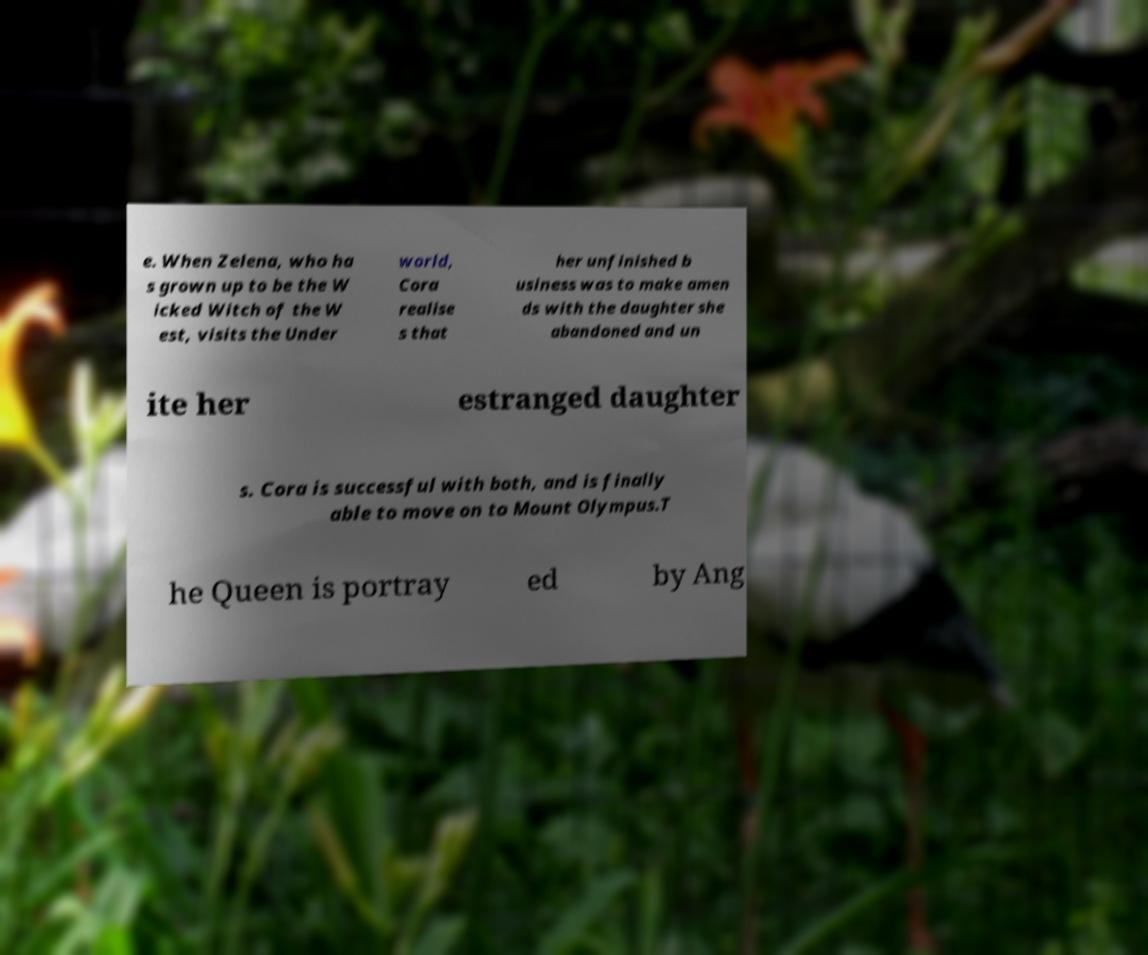For documentation purposes, I need the text within this image transcribed. Could you provide that? e. When Zelena, who ha s grown up to be the W icked Witch of the W est, visits the Under world, Cora realise s that her unfinished b usiness was to make amen ds with the daughter she abandoned and un ite her estranged daughter s. Cora is successful with both, and is finally able to move on to Mount Olympus.T he Queen is portray ed by Ang 